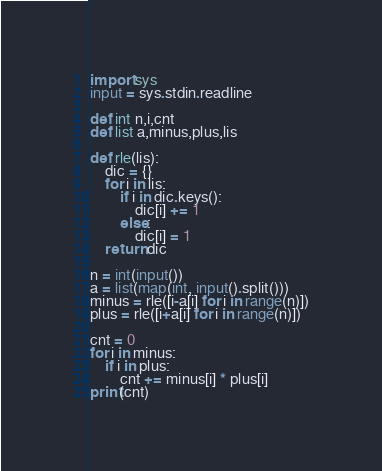<code> <loc_0><loc_0><loc_500><loc_500><_Cython_>import sys
input = sys.stdin.readline

def int n,i,cnt
def list a,minus,plus,lis

def rle(lis):
    dic = {}
    for i in lis:
        if i in dic.keys():
            dic[i] += 1
        else:
            dic[i] = 1
    return dic

n = int(input())
a = list(map(int, input().split()))
minus = rle([i-a[i] for i in range(n)])
plus = rle([i+a[i] for i in range(n)])

cnt = 0
for i in minus:
    if i in plus:
        cnt += minus[i] * plus[i]
print(cnt)
</code> 